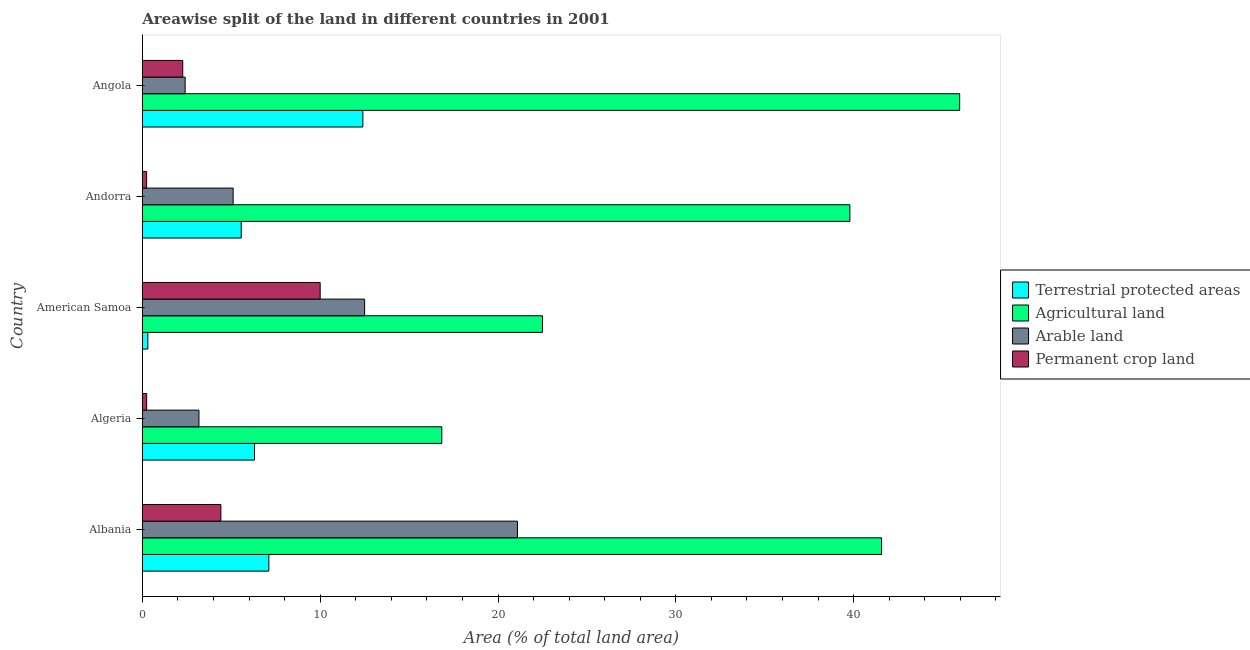Are the number of bars per tick equal to the number of legend labels?
Offer a very short reply. Yes. Are the number of bars on each tick of the Y-axis equal?
Offer a terse response. Yes. How many bars are there on the 5th tick from the bottom?
Make the answer very short. 4. What is the label of the 3rd group of bars from the top?
Your response must be concise. American Samoa. In how many cases, is the number of bars for a given country not equal to the number of legend labels?
Your answer should be very brief. 0. What is the percentage of area under permanent crop land in American Samoa?
Offer a very short reply. 10. Across all countries, what is the maximum percentage of land under terrestrial protection?
Ensure brevity in your answer.  12.4. Across all countries, what is the minimum percentage of area under agricultural land?
Provide a short and direct response. 16.84. In which country was the percentage of land under terrestrial protection maximum?
Offer a terse response. Angola. In which country was the percentage of area under permanent crop land minimum?
Ensure brevity in your answer.  Andorra. What is the total percentage of area under permanent crop land in the graph?
Provide a succinct answer. 17.17. What is the difference between the percentage of area under permanent crop land in American Samoa and that in Andorra?
Offer a terse response. 9.76. What is the difference between the percentage of area under arable land in Andorra and the percentage of land under terrestrial protection in Algeria?
Keep it short and to the point. -1.2. What is the average percentage of area under agricultural land per country?
Keep it short and to the point. 33.33. What is the difference between the percentage of area under agricultural land and percentage of land under terrestrial protection in Andorra?
Offer a terse response. 34.23. What is the ratio of the percentage of area under permanent crop land in Albania to that in Algeria?
Your answer should be very brief. 18.13. Is the percentage of area under agricultural land in American Samoa less than that in Angola?
Ensure brevity in your answer.  Yes. What is the difference between the highest and the second highest percentage of area under agricultural land?
Provide a short and direct response. 4.39. What is the difference between the highest and the lowest percentage of land under terrestrial protection?
Provide a short and direct response. 12.09. In how many countries, is the percentage of area under arable land greater than the average percentage of area under arable land taken over all countries?
Provide a succinct answer. 2. What does the 3rd bar from the top in Albania represents?
Your response must be concise. Agricultural land. What does the 2nd bar from the bottom in Albania represents?
Your answer should be very brief. Agricultural land. How many bars are there?
Make the answer very short. 20. How many countries are there in the graph?
Your answer should be very brief. 5. Are the values on the major ticks of X-axis written in scientific E-notation?
Offer a terse response. No. Does the graph contain grids?
Ensure brevity in your answer.  No. Where does the legend appear in the graph?
Provide a succinct answer. Center right. How many legend labels are there?
Provide a succinct answer. 4. What is the title of the graph?
Keep it short and to the point. Areawise split of the land in different countries in 2001. What is the label or title of the X-axis?
Provide a short and direct response. Area (% of total land area). What is the Area (% of total land area) of Terrestrial protected areas in Albania?
Make the answer very short. 7.11. What is the Area (% of total land area) in Agricultural land in Albania?
Ensure brevity in your answer.  41.57. What is the Area (% of total land area) in Arable land in Albania?
Offer a terse response. 21.09. What is the Area (% of total land area) in Permanent crop land in Albania?
Provide a short and direct response. 4.42. What is the Area (% of total land area) in Terrestrial protected areas in Algeria?
Offer a terse response. 6.31. What is the Area (% of total land area) of Agricultural land in Algeria?
Provide a succinct answer. 16.84. What is the Area (% of total land area) of Arable land in Algeria?
Provide a short and direct response. 3.18. What is the Area (% of total land area) in Permanent crop land in Algeria?
Your answer should be compact. 0.24. What is the Area (% of total land area) of Terrestrial protected areas in American Samoa?
Keep it short and to the point. 0.31. What is the Area (% of total land area) in Agricultural land in American Samoa?
Your answer should be very brief. 22.5. What is the Area (% of total land area) of Terrestrial protected areas in Andorra?
Give a very brief answer. 5.56. What is the Area (% of total land area) in Agricultural land in Andorra?
Offer a very short reply. 39.79. What is the Area (% of total land area) in Arable land in Andorra?
Offer a terse response. 5.11. What is the Area (% of total land area) of Permanent crop land in Andorra?
Ensure brevity in your answer.  0.24. What is the Area (% of total land area) of Terrestrial protected areas in Angola?
Provide a short and direct response. 12.4. What is the Area (% of total land area) in Agricultural land in Angola?
Ensure brevity in your answer.  45.96. What is the Area (% of total land area) of Arable land in Angola?
Make the answer very short. 2.41. What is the Area (% of total land area) in Permanent crop land in Angola?
Provide a short and direct response. 2.27. Across all countries, what is the maximum Area (% of total land area) of Terrestrial protected areas?
Keep it short and to the point. 12.4. Across all countries, what is the maximum Area (% of total land area) of Agricultural land?
Your response must be concise. 45.96. Across all countries, what is the maximum Area (% of total land area) in Arable land?
Offer a terse response. 21.09. Across all countries, what is the maximum Area (% of total land area) in Permanent crop land?
Ensure brevity in your answer.  10. Across all countries, what is the minimum Area (% of total land area) in Terrestrial protected areas?
Keep it short and to the point. 0.31. Across all countries, what is the minimum Area (% of total land area) of Agricultural land?
Provide a short and direct response. 16.84. Across all countries, what is the minimum Area (% of total land area) in Arable land?
Offer a terse response. 2.41. Across all countries, what is the minimum Area (% of total land area) in Permanent crop land?
Your response must be concise. 0.24. What is the total Area (% of total land area) of Terrestrial protected areas in the graph?
Your answer should be compact. 31.69. What is the total Area (% of total land area) in Agricultural land in the graph?
Make the answer very short. 166.66. What is the total Area (% of total land area) in Arable land in the graph?
Give a very brief answer. 44.29. What is the total Area (% of total land area) of Permanent crop land in the graph?
Give a very brief answer. 17.17. What is the difference between the Area (% of total land area) in Terrestrial protected areas in Albania and that in Algeria?
Provide a succinct answer. 0.81. What is the difference between the Area (% of total land area) of Agricultural land in Albania and that in Algeria?
Give a very brief answer. 24.73. What is the difference between the Area (% of total land area) of Arable land in Albania and that in Algeria?
Ensure brevity in your answer.  17.91. What is the difference between the Area (% of total land area) in Permanent crop land in Albania and that in Algeria?
Offer a very short reply. 4.17. What is the difference between the Area (% of total land area) in Terrestrial protected areas in Albania and that in American Samoa?
Give a very brief answer. 6.8. What is the difference between the Area (% of total land area) in Agricultural land in Albania and that in American Samoa?
Provide a succinct answer. 19.07. What is the difference between the Area (% of total land area) in Arable land in Albania and that in American Samoa?
Give a very brief answer. 8.59. What is the difference between the Area (% of total land area) of Permanent crop land in Albania and that in American Samoa?
Give a very brief answer. -5.58. What is the difference between the Area (% of total land area) of Terrestrial protected areas in Albania and that in Andorra?
Keep it short and to the point. 1.55. What is the difference between the Area (% of total land area) of Agricultural land in Albania and that in Andorra?
Make the answer very short. 1.78. What is the difference between the Area (% of total land area) in Arable land in Albania and that in Andorra?
Provide a succinct answer. 15.99. What is the difference between the Area (% of total land area) in Permanent crop land in Albania and that in Andorra?
Your answer should be compact. 4.18. What is the difference between the Area (% of total land area) in Terrestrial protected areas in Albania and that in Angola?
Offer a very short reply. -5.29. What is the difference between the Area (% of total land area) in Agricultural land in Albania and that in Angola?
Give a very brief answer. -4.39. What is the difference between the Area (% of total land area) of Arable land in Albania and that in Angola?
Give a very brief answer. 18.69. What is the difference between the Area (% of total land area) of Permanent crop land in Albania and that in Angola?
Ensure brevity in your answer.  2.14. What is the difference between the Area (% of total land area) of Terrestrial protected areas in Algeria and that in American Samoa?
Keep it short and to the point. 6. What is the difference between the Area (% of total land area) of Agricultural land in Algeria and that in American Samoa?
Provide a short and direct response. -5.66. What is the difference between the Area (% of total land area) of Arable land in Algeria and that in American Samoa?
Your response must be concise. -9.32. What is the difference between the Area (% of total land area) in Permanent crop land in Algeria and that in American Samoa?
Offer a very short reply. -9.76. What is the difference between the Area (% of total land area) of Terrestrial protected areas in Algeria and that in Andorra?
Your answer should be compact. 0.75. What is the difference between the Area (% of total land area) in Agricultural land in Algeria and that in Andorra?
Make the answer very short. -22.95. What is the difference between the Area (% of total land area) in Arable land in Algeria and that in Andorra?
Your answer should be compact. -1.92. What is the difference between the Area (% of total land area) of Permanent crop land in Algeria and that in Andorra?
Provide a short and direct response. 0. What is the difference between the Area (% of total land area) of Terrestrial protected areas in Algeria and that in Angola?
Keep it short and to the point. -6.09. What is the difference between the Area (% of total land area) of Agricultural land in Algeria and that in Angola?
Your response must be concise. -29.12. What is the difference between the Area (% of total land area) of Arable land in Algeria and that in Angola?
Keep it short and to the point. 0.78. What is the difference between the Area (% of total land area) in Permanent crop land in Algeria and that in Angola?
Offer a terse response. -2.03. What is the difference between the Area (% of total land area) in Terrestrial protected areas in American Samoa and that in Andorra?
Provide a short and direct response. -5.25. What is the difference between the Area (% of total land area) of Agricultural land in American Samoa and that in Andorra?
Offer a terse response. -17.29. What is the difference between the Area (% of total land area) in Arable land in American Samoa and that in Andorra?
Keep it short and to the point. 7.39. What is the difference between the Area (% of total land area) in Permanent crop land in American Samoa and that in Andorra?
Give a very brief answer. 9.76. What is the difference between the Area (% of total land area) in Terrestrial protected areas in American Samoa and that in Angola?
Provide a short and direct response. -12.09. What is the difference between the Area (% of total land area) in Agricultural land in American Samoa and that in Angola?
Your answer should be compact. -23.46. What is the difference between the Area (% of total land area) of Arable land in American Samoa and that in Angola?
Provide a short and direct response. 10.09. What is the difference between the Area (% of total land area) in Permanent crop land in American Samoa and that in Angola?
Offer a terse response. 7.73. What is the difference between the Area (% of total land area) of Terrestrial protected areas in Andorra and that in Angola?
Ensure brevity in your answer.  -6.84. What is the difference between the Area (% of total land area) of Agricultural land in Andorra and that in Angola?
Ensure brevity in your answer.  -6.17. What is the difference between the Area (% of total land area) in Permanent crop land in Andorra and that in Angola?
Make the answer very short. -2.03. What is the difference between the Area (% of total land area) of Terrestrial protected areas in Albania and the Area (% of total land area) of Agricultural land in Algeria?
Keep it short and to the point. -9.73. What is the difference between the Area (% of total land area) of Terrestrial protected areas in Albania and the Area (% of total land area) of Arable land in Algeria?
Offer a terse response. 3.93. What is the difference between the Area (% of total land area) of Terrestrial protected areas in Albania and the Area (% of total land area) of Permanent crop land in Algeria?
Make the answer very short. 6.87. What is the difference between the Area (% of total land area) of Agricultural land in Albania and the Area (% of total land area) of Arable land in Algeria?
Provide a short and direct response. 38.39. What is the difference between the Area (% of total land area) of Agricultural land in Albania and the Area (% of total land area) of Permanent crop land in Algeria?
Your response must be concise. 41.33. What is the difference between the Area (% of total land area) in Arable land in Albania and the Area (% of total land area) in Permanent crop land in Algeria?
Ensure brevity in your answer.  20.85. What is the difference between the Area (% of total land area) in Terrestrial protected areas in Albania and the Area (% of total land area) in Agricultural land in American Samoa?
Your answer should be very brief. -15.39. What is the difference between the Area (% of total land area) of Terrestrial protected areas in Albania and the Area (% of total land area) of Arable land in American Samoa?
Make the answer very short. -5.39. What is the difference between the Area (% of total land area) of Terrestrial protected areas in Albania and the Area (% of total land area) of Permanent crop land in American Samoa?
Offer a very short reply. -2.89. What is the difference between the Area (% of total land area) of Agricultural land in Albania and the Area (% of total land area) of Arable land in American Samoa?
Your answer should be compact. 29.07. What is the difference between the Area (% of total land area) in Agricultural land in Albania and the Area (% of total land area) in Permanent crop land in American Samoa?
Your answer should be very brief. 31.57. What is the difference between the Area (% of total land area) of Arable land in Albania and the Area (% of total land area) of Permanent crop land in American Samoa?
Keep it short and to the point. 11.09. What is the difference between the Area (% of total land area) in Terrestrial protected areas in Albania and the Area (% of total land area) in Agricultural land in Andorra?
Offer a very short reply. -32.67. What is the difference between the Area (% of total land area) in Terrestrial protected areas in Albania and the Area (% of total land area) in Arable land in Andorra?
Provide a short and direct response. 2.01. What is the difference between the Area (% of total land area) of Terrestrial protected areas in Albania and the Area (% of total land area) of Permanent crop land in Andorra?
Offer a terse response. 6.87. What is the difference between the Area (% of total land area) of Agricultural land in Albania and the Area (% of total land area) of Arable land in Andorra?
Offer a terse response. 36.46. What is the difference between the Area (% of total land area) of Agricultural land in Albania and the Area (% of total land area) of Permanent crop land in Andorra?
Provide a succinct answer. 41.33. What is the difference between the Area (% of total land area) in Arable land in Albania and the Area (% of total land area) in Permanent crop land in Andorra?
Keep it short and to the point. 20.85. What is the difference between the Area (% of total land area) in Terrestrial protected areas in Albania and the Area (% of total land area) in Agricultural land in Angola?
Make the answer very short. -38.85. What is the difference between the Area (% of total land area) in Terrestrial protected areas in Albania and the Area (% of total land area) in Arable land in Angola?
Your response must be concise. 4.71. What is the difference between the Area (% of total land area) in Terrestrial protected areas in Albania and the Area (% of total land area) in Permanent crop land in Angola?
Give a very brief answer. 4.84. What is the difference between the Area (% of total land area) of Agricultural land in Albania and the Area (% of total land area) of Arable land in Angola?
Provide a short and direct response. 39.16. What is the difference between the Area (% of total land area) of Agricultural land in Albania and the Area (% of total land area) of Permanent crop land in Angola?
Make the answer very short. 39.3. What is the difference between the Area (% of total land area) of Arable land in Albania and the Area (% of total land area) of Permanent crop land in Angola?
Offer a very short reply. 18.82. What is the difference between the Area (% of total land area) in Terrestrial protected areas in Algeria and the Area (% of total land area) in Agricultural land in American Samoa?
Give a very brief answer. -16.19. What is the difference between the Area (% of total land area) in Terrestrial protected areas in Algeria and the Area (% of total land area) in Arable land in American Samoa?
Your answer should be compact. -6.19. What is the difference between the Area (% of total land area) of Terrestrial protected areas in Algeria and the Area (% of total land area) of Permanent crop land in American Samoa?
Your response must be concise. -3.69. What is the difference between the Area (% of total land area) of Agricultural land in Algeria and the Area (% of total land area) of Arable land in American Samoa?
Provide a succinct answer. 4.34. What is the difference between the Area (% of total land area) of Agricultural land in Algeria and the Area (% of total land area) of Permanent crop land in American Samoa?
Your answer should be compact. 6.84. What is the difference between the Area (% of total land area) of Arable land in Algeria and the Area (% of total land area) of Permanent crop land in American Samoa?
Your answer should be compact. -6.82. What is the difference between the Area (% of total land area) in Terrestrial protected areas in Algeria and the Area (% of total land area) in Agricultural land in Andorra?
Offer a very short reply. -33.48. What is the difference between the Area (% of total land area) of Terrestrial protected areas in Algeria and the Area (% of total land area) of Arable land in Andorra?
Ensure brevity in your answer.  1.2. What is the difference between the Area (% of total land area) in Terrestrial protected areas in Algeria and the Area (% of total land area) in Permanent crop land in Andorra?
Keep it short and to the point. 6.07. What is the difference between the Area (% of total land area) of Agricultural land in Algeria and the Area (% of total land area) of Arable land in Andorra?
Offer a terse response. 11.73. What is the difference between the Area (% of total land area) in Agricultural land in Algeria and the Area (% of total land area) in Permanent crop land in Andorra?
Give a very brief answer. 16.6. What is the difference between the Area (% of total land area) in Arable land in Algeria and the Area (% of total land area) in Permanent crop land in Andorra?
Your answer should be very brief. 2.94. What is the difference between the Area (% of total land area) in Terrestrial protected areas in Algeria and the Area (% of total land area) in Agricultural land in Angola?
Give a very brief answer. -39.65. What is the difference between the Area (% of total land area) in Terrestrial protected areas in Algeria and the Area (% of total land area) in Arable land in Angola?
Give a very brief answer. 3.9. What is the difference between the Area (% of total land area) of Terrestrial protected areas in Algeria and the Area (% of total land area) of Permanent crop land in Angola?
Keep it short and to the point. 4.04. What is the difference between the Area (% of total land area) of Agricultural land in Algeria and the Area (% of total land area) of Arable land in Angola?
Provide a succinct answer. 14.43. What is the difference between the Area (% of total land area) in Agricultural land in Algeria and the Area (% of total land area) in Permanent crop land in Angola?
Give a very brief answer. 14.57. What is the difference between the Area (% of total land area) in Arable land in Algeria and the Area (% of total land area) in Permanent crop land in Angola?
Offer a terse response. 0.91. What is the difference between the Area (% of total land area) in Terrestrial protected areas in American Samoa and the Area (% of total land area) in Agricultural land in Andorra?
Offer a terse response. -39.48. What is the difference between the Area (% of total land area) in Terrestrial protected areas in American Samoa and the Area (% of total land area) in Arable land in Andorra?
Provide a short and direct response. -4.8. What is the difference between the Area (% of total land area) in Terrestrial protected areas in American Samoa and the Area (% of total land area) in Permanent crop land in Andorra?
Your response must be concise. 0.07. What is the difference between the Area (% of total land area) in Agricultural land in American Samoa and the Area (% of total land area) in Arable land in Andorra?
Give a very brief answer. 17.39. What is the difference between the Area (% of total land area) in Agricultural land in American Samoa and the Area (% of total land area) in Permanent crop land in Andorra?
Your response must be concise. 22.26. What is the difference between the Area (% of total land area) in Arable land in American Samoa and the Area (% of total land area) in Permanent crop land in Andorra?
Keep it short and to the point. 12.26. What is the difference between the Area (% of total land area) of Terrestrial protected areas in American Samoa and the Area (% of total land area) of Agricultural land in Angola?
Offer a terse response. -45.65. What is the difference between the Area (% of total land area) of Terrestrial protected areas in American Samoa and the Area (% of total land area) of Arable land in Angola?
Provide a succinct answer. -2.1. What is the difference between the Area (% of total land area) in Terrestrial protected areas in American Samoa and the Area (% of total land area) in Permanent crop land in Angola?
Your answer should be very brief. -1.96. What is the difference between the Area (% of total land area) in Agricultural land in American Samoa and the Area (% of total land area) in Arable land in Angola?
Keep it short and to the point. 20.09. What is the difference between the Area (% of total land area) in Agricultural land in American Samoa and the Area (% of total land area) in Permanent crop land in Angola?
Offer a terse response. 20.23. What is the difference between the Area (% of total land area) of Arable land in American Samoa and the Area (% of total land area) of Permanent crop land in Angola?
Your answer should be compact. 10.23. What is the difference between the Area (% of total land area) in Terrestrial protected areas in Andorra and the Area (% of total land area) in Agricultural land in Angola?
Provide a succinct answer. -40.4. What is the difference between the Area (% of total land area) in Terrestrial protected areas in Andorra and the Area (% of total land area) in Arable land in Angola?
Keep it short and to the point. 3.15. What is the difference between the Area (% of total land area) of Terrestrial protected areas in Andorra and the Area (% of total land area) of Permanent crop land in Angola?
Offer a very short reply. 3.29. What is the difference between the Area (% of total land area) of Agricultural land in Andorra and the Area (% of total land area) of Arable land in Angola?
Your answer should be compact. 37.38. What is the difference between the Area (% of total land area) of Agricultural land in Andorra and the Area (% of total land area) of Permanent crop land in Angola?
Your answer should be compact. 37.51. What is the difference between the Area (% of total land area) of Arable land in Andorra and the Area (% of total land area) of Permanent crop land in Angola?
Your answer should be compact. 2.83. What is the average Area (% of total land area) in Terrestrial protected areas per country?
Offer a very short reply. 6.34. What is the average Area (% of total land area) of Agricultural land per country?
Your response must be concise. 33.33. What is the average Area (% of total land area) in Arable land per country?
Provide a succinct answer. 8.86. What is the average Area (% of total land area) of Permanent crop land per country?
Provide a succinct answer. 3.43. What is the difference between the Area (% of total land area) in Terrestrial protected areas and Area (% of total land area) in Agricultural land in Albania?
Your response must be concise. -34.46. What is the difference between the Area (% of total land area) of Terrestrial protected areas and Area (% of total land area) of Arable land in Albania?
Ensure brevity in your answer.  -13.98. What is the difference between the Area (% of total land area) in Terrestrial protected areas and Area (% of total land area) in Permanent crop land in Albania?
Provide a short and direct response. 2.7. What is the difference between the Area (% of total land area) of Agricultural land and Area (% of total land area) of Arable land in Albania?
Offer a terse response. 20.47. What is the difference between the Area (% of total land area) of Agricultural land and Area (% of total land area) of Permanent crop land in Albania?
Provide a short and direct response. 37.15. What is the difference between the Area (% of total land area) of Arable land and Area (% of total land area) of Permanent crop land in Albania?
Your response must be concise. 16.68. What is the difference between the Area (% of total land area) of Terrestrial protected areas and Area (% of total land area) of Agricultural land in Algeria?
Provide a succinct answer. -10.53. What is the difference between the Area (% of total land area) in Terrestrial protected areas and Area (% of total land area) in Arable land in Algeria?
Provide a short and direct response. 3.12. What is the difference between the Area (% of total land area) of Terrestrial protected areas and Area (% of total land area) of Permanent crop land in Algeria?
Ensure brevity in your answer.  6.06. What is the difference between the Area (% of total land area) of Agricultural land and Area (% of total land area) of Arable land in Algeria?
Make the answer very short. 13.66. What is the difference between the Area (% of total land area) in Agricultural land and Area (% of total land area) in Permanent crop land in Algeria?
Provide a succinct answer. 16.6. What is the difference between the Area (% of total land area) in Arable land and Area (% of total land area) in Permanent crop land in Algeria?
Provide a succinct answer. 2.94. What is the difference between the Area (% of total land area) in Terrestrial protected areas and Area (% of total land area) in Agricultural land in American Samoa?
Provide a succinct answer. -22.19. What is the difference between the Area (% of total land area) in Terrestrial protected areas and Area (% of total land area) in Arable land in American Samoa?
Your answer should be very brief. -12.19. What is the difference between the Area (% of total land area) in Terrestrial protected areas and Area (% of total land area) in Permanent crop land in American Samoa?
Offer a very short reply. -9.69. What is the difference between the Area (% of total land area) in Arable land and Area (% of total land area) in Permanent crop land in American Samoa?
Keep it short and to the point. 2.5. What is the difference between the Area (% of total land area) of Terrestrial protected areas and Area (% of total land area) of Agricultural land in Andorra?
Make the answer very short. -34.23. What is the difference between the Area (% of total land area) in Terrestrial protected areas and Area (% of total land area) in Arable land in Andorra?
Provide a succinct answer. 0.45. What is the difference between the Area (% of total land area) in Terrestrial protected areas and Area (% of total land area) in Permanent crop land in Andorra?
Your answer should be very brief. 5.32. What is the difference between the Area (% of total land area) in Agricultural land and Area (% of total land area) in Arable land in Andorra?
Ensure brevity in your answer.  34.68. What is the difference between the Area (% of total land area) of Agricultural land and Area (% of total land area) of Permanent crop land in Andorra?
Offer a terse response. 39.55. What is the difference between the Area (% of total land area) in Arable land and Area (% of total land area) in Permanent crop land in Andorra?
Give a very brief answer. 4.87. What is the difference between the Area (% of total land area) in Terrestrial protected areas and Area (% of total land area) in Agricultural land in Angola?
Your answer should be compact. -33.56. What is the difference between the Area (% of total land area) in Terrestrial protected areas and Area (% of total land area) in Arable land in Angola?
Your response must be concise. 9.99. What is the difference between the Area (% of total land area) in Terrestrial protected areas and Area (% of total land area) in Permanent crop land in Angola?
Keep it short and to the point. 10.13. What is the difference between the Area (% of total land area) in Agricultural land and Area (% of total land area) in Arable land in Angola?
Offer a very short reply. 43.55. What is the difference between the Area (% of total land area) of Agricultural land and Area (% of total land area) of Permanent crop land in Angola?
Ensure brevity in your answer.  43.69. What is the difference between the Area (% of total land area) in Arable land and Area (% of total land area) in Permanent crop land in Angola?
Ensure brevity in your answer.  0.13. What is the ratio of the Area (% of total land area) of Terrestrial protected areas in Albania to that in Algeria?
Offer a terse response. 1.13. What is the ratio of the Area (% of total land area) of Agricultural land in Albania to that in Algeria?
Provide a succinct answer. 2.47. What is the ratio of the Area (% of total land area) in Arable land in Albania to that in Algeria?
Offer a very short reply. 6.63. What is the ratio of the Area (% of total land area) in Permanent crop land in Albania to that in Algeria?
Ensure brevity in your answer.  18.13. What is the ratio of the Area (% of total land area) in Terrestrial protected areas in Albania to that in American Samoa?
Provide a succinct answer. 22.94. What is the ratio of the Area (% of total land area) of Agricultural land in Albania to that in American Samoa?
Keep it short and to the point. 1.85. What is the ratio of the Area (% of total land area) in Arable land in Albania to that in American Samoa?
Give a very brief answer. 1.69. What is the ratio of the Area (% of total land area) in Permanent crop land in Albania to that in American Samoa?
Your answer should be very brief. 0.44. What is the ratio of the Area (% of total land area) of Terrestrial protected areas in Albania to that in Andorra?
Your answer should be very brief. 1.28. What is the ratio of the Area (% of total land area) of Agricultural land in Albania to that in Andorra?
Keep it short and to the point. 1.04. What is the ratio of the Area (% of total land area) of Arable land in Albania to that in Andorra?
Keep it short and to the point. 4.13. What is the ratio of the Area (% of total land area) of Permanent crop land in Albania to that in Andorra?
Provide a short and direct response. 18.35. What is the ratio of the Area (% of total land area) in Terrestrial protected areas in Albania to that in Angola?
Your answer should be very brief. 0.57. What is the ratio of the Area (% of total land area) of Agricultural land in Albania to that in Angola?
Keep it short and to the point. 0.9. What is the ratio of the Area (% of total land area) of Arable land in Albania to that in Angola?
Keep it short and to the point. 8.77. What is the ratio of the Area (% of total land area) of Permanent crop land in Albania to that in Angola?
Offer a terse response. 1.94. What is the ratio of the Area (% of total land area) of Terrestrial protected areas in Algeria to that in American Samoa?
Your answer should be compact. 20.34. What is the ratio of the Area (% of total land area) of Agricultural land in Algeria to that in American Samoa?
Keep it short and to the point. 0.75. What is the ratio of the Area (% of total land area) of Arable land in Algeria to that in American Samoa?
Offer a very short reply. 0.25. What is the ratio of the Area (% of total land area) in Permanent crop land in Algeria to that in American Samoa?
Give a very brief answer. 0.02. What is the ratio of the Area (% of total land area) in Terrestrial protected areas in Algeria to that in Andorra?
Make the answer very short. 1.13. What is the ratio of the Area (% of total land area) in Agricultural land in Algeria to that in Andorra?
Provide a short and direct response. 0.42. What is the ratio of the Area (% of total land area) of Arable land in Algeria to that in Andorra?
Your response must be concise. 0.62. What is the ratio of the Area (% of total land area) of Permanent crop land in Algeria to that in Andorra?
Provide a succinct answer. 1.01. What is the ratio of the Area (% of total land area) of Terrestrial protected areas in Algeria to that in Angola?
Provide a short and direct response. 0.51. What is the ratio of the Area (% of total land area) of Agricultural land in Algeria to that in Angola?
Your answer should be very brief. 0.37. What is the ratio of the Area (% of total land area) in Arable land in Algeria to that in Angola?
Offer a terse response. 1.32. What is the ratio of the Area (% of total land area) of Permanent crop land in Algeria to that in Angola?
Offer a very short reply. 0.11. What is the ratio of the Area (% of total land area) of Terrestrial protected areas in American Samoa to that in Andorra?
Ensure brevity in your answer.  0.06. What is the ratio of the Area (% of total land area) of Agricultural land in American Samoa to that in Andorra?
Provide a short and direct response. 0.57. What is the ratio of the Area (% of total land area) in Arable land in American Samoa to that in Andorra?
Keep it short and to the point. 2.45. What is the ratio of the Area (% of total land area) in Permanent crop land in American Samoa to that in Andorra?
Offer a very short reply. 41.56. What is the ratio of the Area (% of total land area) in Terrestrial protected areas in American Samoa to that in Angola?
Provide a succinct answer. 0.03. What is the ratio of the Area (% of total land area) of Agricultural land in American Samoa to that in Angola?
Provide a succinct answer. 0.49. What is the ratio of the Area (% of total land area) of Arable land in American Samoa to that in Angola?
Your response must be concise. 5.19. What is the ratio of the Area (% of total land area) in Permanent crop land in American Samoa to that in Angola?
Provide a short and direct response. 4.4. What is the ratio of the Area (% of total land area) in Terrestrial protected areas in Andorra to that in Angola?
Offer a terse response. 0.45. What is the ratio of the Area (% of total land area) of Agricultural land in Andorra to that in Angola?
Your answer should be compact. 0.87. What is the ratio of the Area (% of total land area) of Arable land in Andorra to that in Angola?
Ensure brevity in your answer.  2.12. What is the ratio of the Area (% of total land area) of Permanent crop land in Andorra to that in Angola?
Offer a terse response. 0.11. What is the difference between the highest and the second highest Area (% of total land area) in Terrestrial protected areas?
Give a very brief answer. 5.29. What is the difference between the highest and the second highest Area (% of total land area) in Agricultural land?
Give a very brief answer. 4.39. What is the difference between the highest and the second highest Area (% of total land area) of Arable land?
Ensure brevity in your answer.  8.59. What is the difference between the highest and the second highest Area (% of total land area) in Permanent crop land?
Your answer should be compact. 5.58. What is the difference between the highest and the lowest Area (% of total land area) of Terrestrial protected areas?
Offer a terse response. 12.09. What is the difference between the highest and the lowest Area (% of total land area) in Agricultural land?
Your answer should be very brief. 29.12. What is the difference between the highest and the lowest Area (% of total land area) in Arable land?
Provide a succinct answer. 18.69. What is the difference between the highest and the lowest Area (% of total land area) in Permanent crop land?
Offer a very short reply. 9.76. 